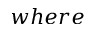<formula> <loc_0><loc_0><loc_500><loc_500>w h e r e</formula> 